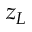Convert formula to latex. <formula><loc_0><loc_0><loc_500><loc_500>z _ { L }</formula> 